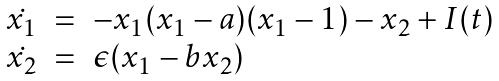<formula> <loc_0><loc_0><loc_500><loc_500>\begin{array} { r c l } \dot { x _ { 1 } } & = & - x _ { 1 } ( x _ { 1 } - a ) ( x _ { 1 } - 1 ) - x _ { 2 } + I ( t ) \\ \dot { x _ { 2 } } & = & \epsilon ( x _ { 1 } - b x _ { 2 } ) \end{array}</formula> 